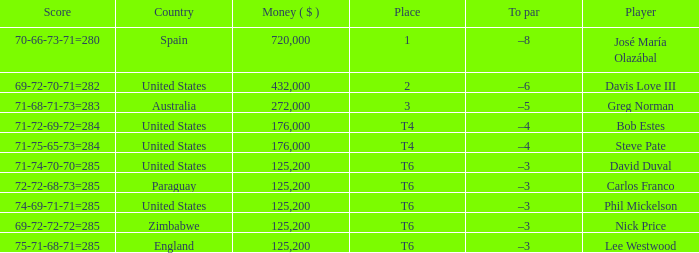Which Score has a Place of t6, and a Country of paraguay? 72-72-68-73=285. 